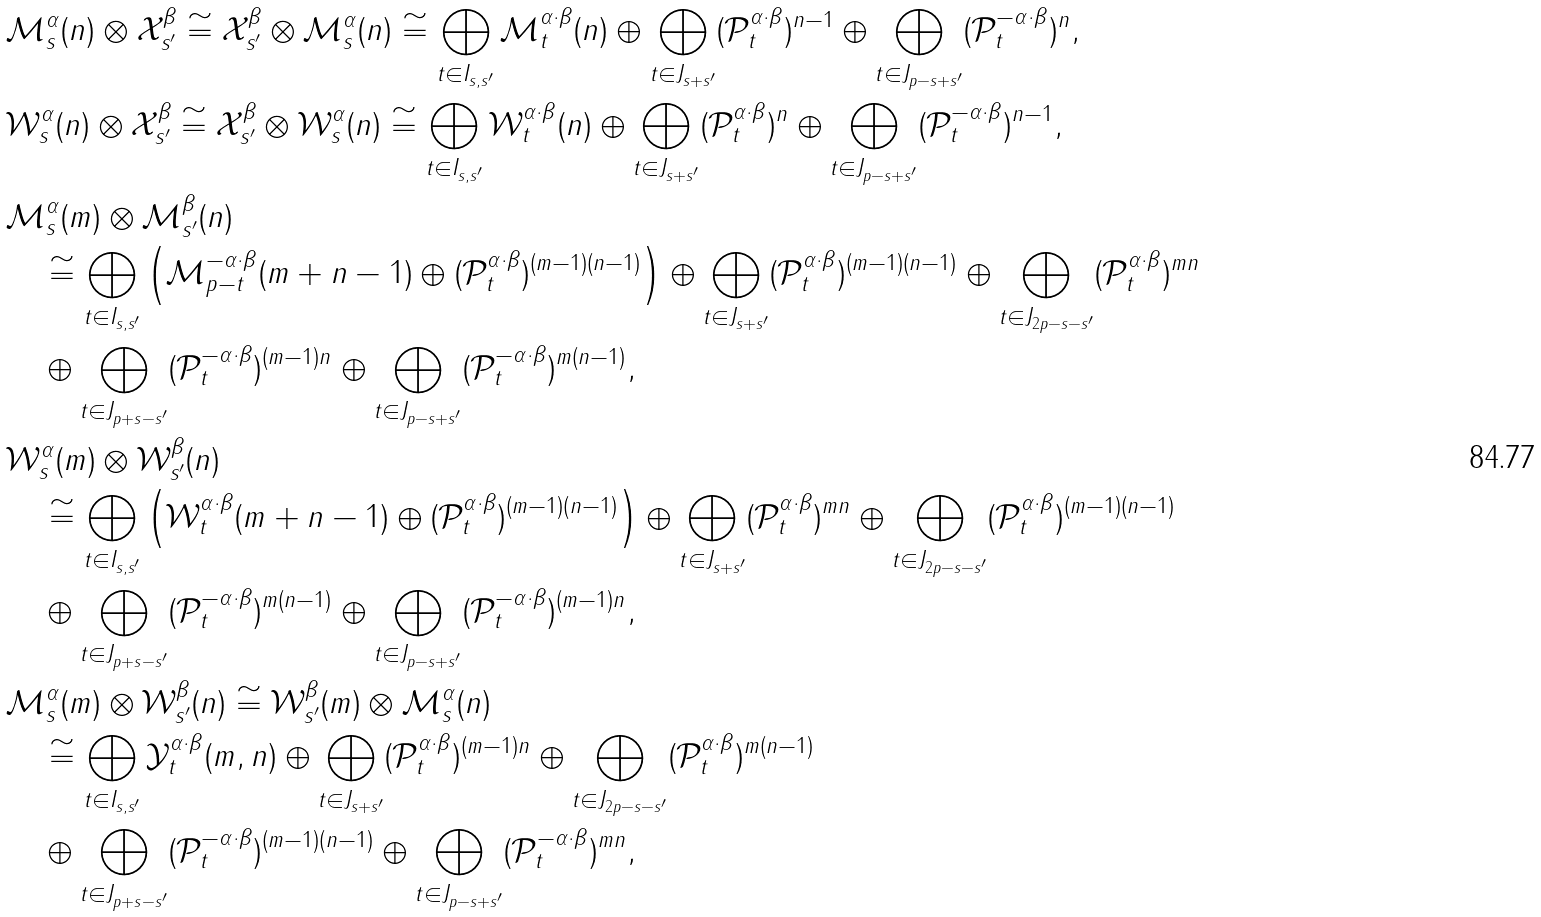Convert formula to latex. <formula><loc_0><loc_0><loc_500><loc_500>& \mathcal { M } _ { s } ^ { \alpha } ( n ) \otimes \mathcal { X } _ { s ^ { \prime } } ^ { \beta } \cong \mathcal { X } _ { s ^ { \prime } } ^ { \beta } \otimes \mathcal { M } _ { s } ^ { \alpha } ( n ) \cong \bigoplus _ { t \in I _ { s , s ^ { \prime } } } \mathcal { M } _ { t } ^ { \alpha \cdot \beta } ( n ) \oplus \bigoplus _ { t \in J _ { s + s ^ { \prime } } } ( \mathcal { P } _ { t } ^ { \alpha \cdot \beta } ) ^ { n - 1 } \oplus \bigoplus _ { t \in J _ { p - s + s ^ { \prime } } } ( \mathcal { P } _ { t } ^ { - \alpha \cdot \beta } ) ^ { n } , \\ & \mathcal { W } _ { s } ^ { \alpha } ( n ) \otimes \mathcal { X } _ { s ^ { \prime } } ^ { \beta } \cong \mathcal { X } _ { s ^ { \prime } } ^ { \beta } \otimes \mathcal { W } _ { s } ^ { \alpha } ( n ) \cong \bigoplus _ { t \in I _ { s , s ^ { \prime } } } \mathcal { W } _ { t } ^ { \alpha \cdot \beta } ( n ) \oplus \bigoplus _ { t \in J _ { s + s ^ { \prime } } } ( \mathcal { P } _ { t } ^ { \alpha \cdot \beta } ) ^ { n } \oplus \bigoplus _ { t \in J _ { p - s + s ^ { \prime } } } ( \mathcal { P } _ { t } ^ { - \alpha \cdot \beta } ) ^ { n - 1 } , \\ & \mathcal { M } _ { s } ^ { \alpha } ( m ) \otimes \mathcal { M } _ { s ^ { \prime } } ^ { \beta } ( n ) \\ & \quad \cong \bigoplus _ { t \in I _ { s , s ^ { \prime } } } \left ( \mathcal { M } _ { p - t } ^ { - \alpha \cdot \beta } ( m + n - 1 ) \oplus ( \mathcal { P } _ { t } ^ { \alpha \cdot \beta } ) ^ { ( m - 1 ) ( n - 1 ) } \right ) \oplus \bigoplus _ { t \in J _ { s + s ^ { \prime } } } ( \mathcal { P } _ { t } ^ { \alpha \cdot \beta } ) ^ { ( m - 1 ) ( n - 1 ) } \oplus \bigoplus _ { t \in J _ { 2 p - s - s ^ { \prime } } } ( \mathcal { P } _ { t } ^ { \alpha \cdot \beta } ) ^ { m n } \\ & \quad \oplus \bigoplus _ { t \in J _ { p + s - s ^ { \prime } } } ( \mathcal { P } _ { t } ^ { - \alpha \cdot \beta } ) ^ { ( m - 1 ) n } \oplus \bigoplus _ { t \in J _ { p - s + s ^ { \prime } } } ( \mathcal { P } _ { t } ^ { - \alpha \cdot \beta } ) ^ { m ( n - 1 ) } , \\ & \mathcal { W } _ { s } ^ { \alpha } ( m ) \otimes \mathcal { W } _ { s ^ { \prime } } ^ { \beta } ( n ) \\ & \quad \cong \bigoplus _ { t \in I _ { s , s ^ { \prime } } } \left ( \mathcal { W } _ { t } ^ { \alpha \cdot \beta } ( m + n - 1 ) \oplus ( \mathcal { P } _ { t } ^ { \alpha \cdot \beta } ) ^ { ( m - 1 ) ( n - 1 ) } \right ) \oplus \bigoplus _ { t \in J _ { s + s ^ { \prime } } } ( \mathcal { P } _ { t } ^ { \alpha \cdot \beta } ) ^ { m n } \oplus \bigoplus _ { t \in J _ { 2 p - s - s ^ { \prime } } } ( \mathcal { P } _ { t } ^ { \alpha \cdot \beta } ) ^ { ( m - 1 ) ( n - 1 ) } \\ & \quad \oplus \bigoplus _ { t \in J _ { p + s - s ^ { \prime } } } ( \mathcal { P } _ { t } ^ { - \alpha \cdot \beta } ) ^ { m ( n - 1 ) } \oplus \bigoplus _ { t \in J _ { p - s + s ^ { \prime } } } ( \mathcal { P } _ { t } ^ { - \alpha \cdot \beta } ) ^ { ( m - 1 ) n } , \\ & \mathcal { M } _ { s } ^ { \alpha } ( m ) \otimes \mathcal { W } _ { s ^ { \prime } } ^ { \beta } ( n ) \cong \mathcal { W } _ { s ^ { \prime } } ^ { \beta } ( m ) \otimes \mathcal { M } _ { s } ^ { \alpha } ( n ) \\ & \quad \cong \bigoplus _ { t \in I _ { s , s ^ { \prime } } } \mathcal { Y } _ { t } ^ { \alpha \cdot \beta } ( m , n ) \oplus \bigoplus _ { t \in J _ { s + s ^ { \prime } } } ( \mathcal { P } _ { t } ^ { \alpha \cdot \beta } ) ^ { ( m - 1 ) n } \oplus \bigoplus _ { t \in J _ { 2 p - s - s ^ { \prime } } } ( \mathcal { P } _ { t } ^ { \alpha \cdot \beta } ) ^ { m ( n - 1 ) } \\ & \quad \oplus \bigoplus _ { t \in J _ { p + s - s ^ { \prime } } } ( \mathcal { P } _ { t } ^ { - \alpha \cdot \beta } ) ^ { ( m - 1 ) ( n - 1 ) } \oplus \bigoplus _ { t \in J _ { p - s + s ^ { \prime } } } ( \mathcal { P } _ { t } ^ { - \alpha \cdot \beta } ) ^ { m n } ,</formula> 